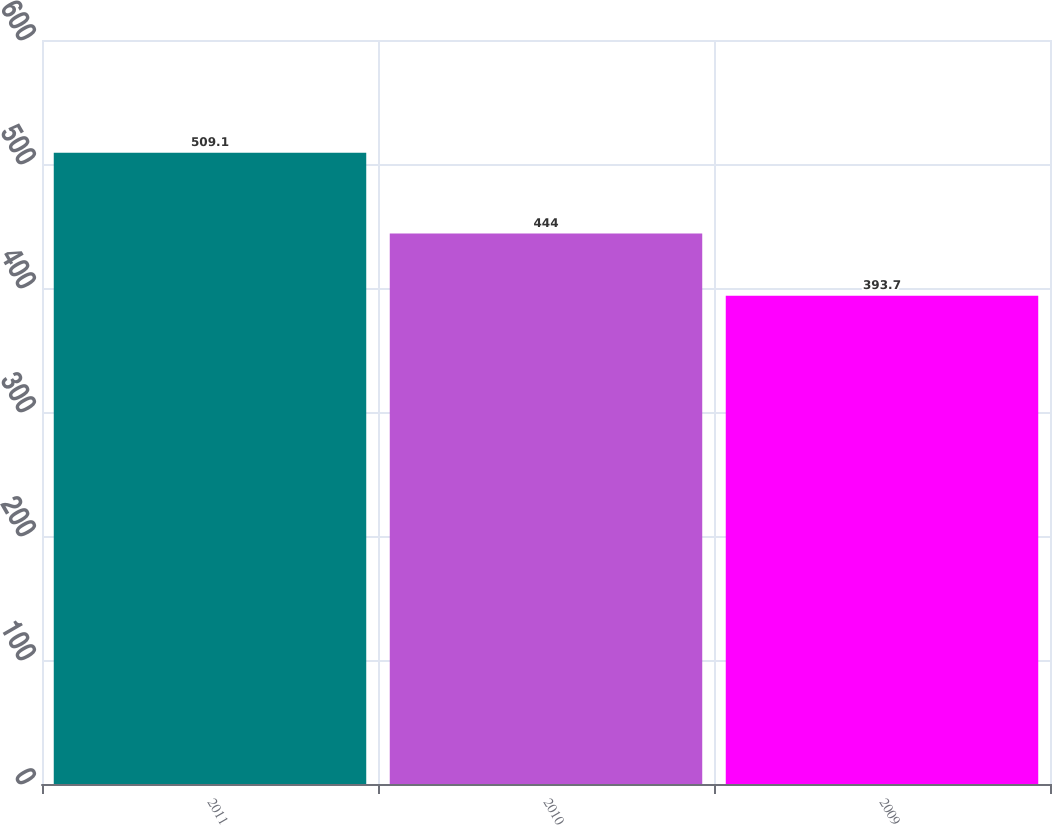Convert chart to OTSL. <chart><loc_0><loc_0><loc_500><loc_500><bar_chart><fcel>2011<fcel>2010<fcel>2009<nl><fcel>509.1<fcel>444<fcel>393.7<nl></chart> 